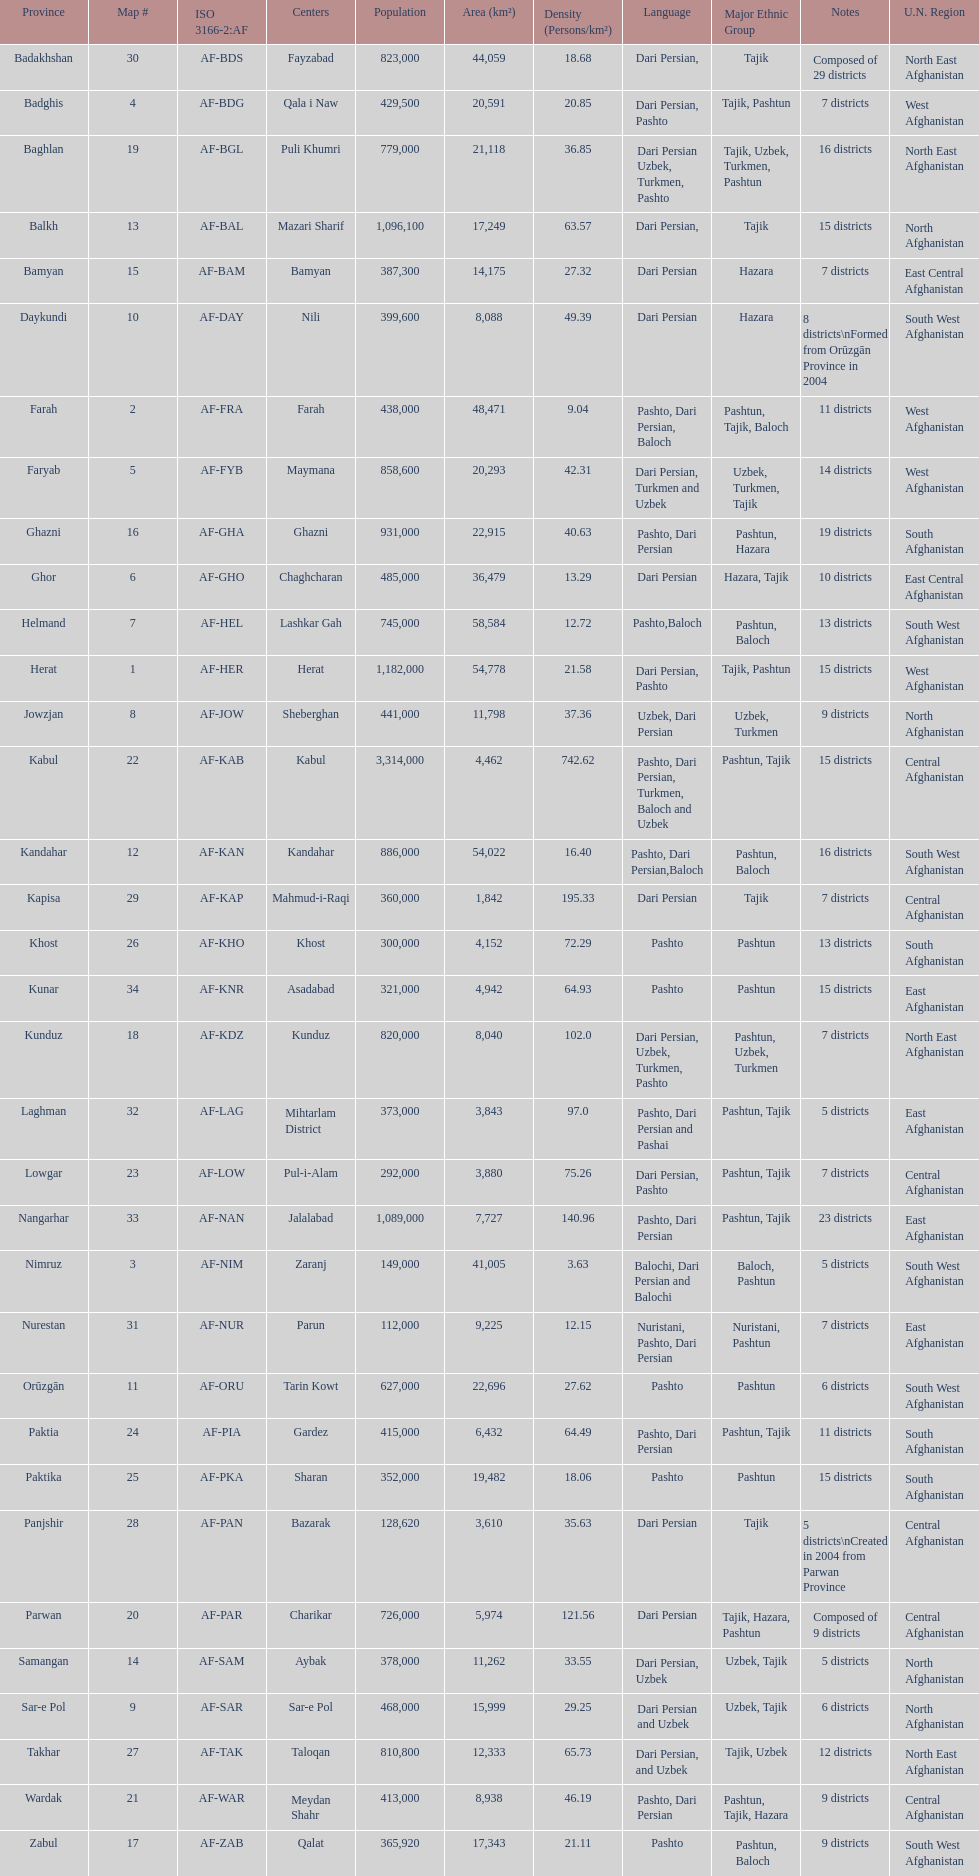How many provinces have pashto as one of their languages 20. Give me the full table as a dictionary. {'header': ['Province', 'Map #', 'ISO 3166-2:AF', 'Centers', 'Population', 'Area (km²)', 'Density (Persons/km²)', 'Language', 'Major Ethnic Group', 'Notes', 'U.N. Region'], 'rows': [['Badakhshan', '30', 'AF-BDS', 'Fayzabad', '823,000', '44,059', '18.68', 'Dari Persian,', 'Tajik', 'Composed of 29 districts', 'North East Afghanistan'], ['Badghis', '4', 'AF-BDG', 'Qala i Naw', '429,500', '20,591', '20.85', 'Dari Persian, Pashto', 'Tajik, Pashtun', '7 districts', 'West Afghanistan'], ['Baghlan', '19', 'AF-BGL', 'Puli Khumri', '779,000', '21,118', '36.85', 'Dari Persian Uzbek, Turkmen, Pashto', 'Tajik, Uzbek, Turkmen, Pashtun', '16 districts', 'North East Afghanistan'], ['Balkh', '13', 'AF-BAL', 'Mazari Sharif', '1,096,100', '17,249', '63.57', 'Dari Persian,', 'Tajik', '15 districts', 'North Afghanistan'], ['Bamyan', '15', 'AF-BAM', 'Bamyan', '387,300', '14,175', '27.32', 'Dari Persian', 'Hazara', '7 districts', 'East Central Afghanistan'], ['Daykundi', '10', 'AF-DAY', 'Nili', '399,600', '8,088', '49.39', 'Dari Persian', 'Hazara', '8 districts\\nFormed from Orūzgān Province in 2004', 'South West Afghanistan'], ['Farah', '2', 'AF-FRA', 'Farah', '438,000', '48,471', '9.04', 'Pashto, Dari Persian, Baloch', 'Pashtun, Tajik, Baloch', '11 districts', 'West Afghanistan'], ['Faryab', '5', 'AF-FYB', 'Maymana', '858,600', '20,293', '42.31', 'Dari Persian, Turkmen and Uzbek', 'Uzbek, Turkmen, Tajik', '14 districts', 'West Afghanistan'], ['Ghazni', '16', 'AF-GHA', 'Ghazni', '931,000', '22,915', '40.63', 'Pashto, Dari Persian', 'Pashtun, Hazara', '19 districts', 'South Afghanistan'], ['Ghor', '6', 'AF-GHO', 'Chaghcharan', '485,000', '36,479', '13.29', 'Dari Persian', 'Hazara, Tajik', '10 districts', 'East Central Afghanistan'], ['Helmand', '7', 'AF-HEL', 'Lashkar Gah', '745,000', '58,584', '12.72', 'Pashto,Baloch', 'Pashtun, Baloch', '13 districts', 'South West Afghanistan'], ['Herat', '1', 'AF-HER', 'Herat', '1,182,000', '54,778', '21.58', 'Dari Persian, Pashto', 'Tajik, Pashtun', '15 districts', 'West Afghanistan'], ['Jowzjan', '8', 'AF-JOW', 'Sheberghan', '441,000', '11,798', '37.36', 'Uzbek, Dari Persian', 'Uzbek, Turkmen', '9 districts', 'North Afghanistan'], ['Kabul', '22', 'AF-KAB', 'Kabul', '3,314,000', '4,462', '742.62', 'Pashto, Dari Persian, Turkmen, Baloch and Uzbek', 'Pashtun, Tajik', '15 districts', 'Central Afghanistan'], ['Kandahar', '12', 'AF-KAN', 'Kandahar', '886,000', '54,022', '16.40', 'Pashto, Dari Persian,Baloch', 'Pashtun, Baloch', '16 districts', 'South West Afghanistan'], ['Kapisa', '29', 'AF-KAP', 'Mahmud-i-Raqi', '360,000', '1,842', '195.33', 'Dari Persian', 'Tajik', '7 districts', 'Central Afghanistan'], ['Khost', '26', 'AF-KHO', 'Khost', '300,000', '4,152', '72.29', 'Pashto', 'Pashtun', '13 districts', 'South Afghanistan'], ['Kunar', '34', 'AF-KNR', 'Asadabad', '321,000', '4,942', '64.93', 'Pashto', 'Pashtun', '15 districts', 'East Afghanistan'], ['Kunduz', '18', 'AF-KDZ', 'Kunduz', '820,000', '8,040', '102.0', 'Dari Persian, Uzbek, Turkmen, Pashto', 'Pashtun, Uzbek, Turkmen', '7 districts', 'North East Afghanistan'], ['Laghman', '32', 'AF-LAG', 'Mihtarlam District', '373,000', '3,843', '97.0', 'Pashto, Dari Persian and Pashai', 'Pashtun, Tajik', '5 districts', 'East Afghanistan'], ['Lowgar', '23', 'AF-LOW', 'Pul-i-Alam', '292,000', '3,880', '75.26', 'Dari Persian, Pashto', 'Pashtun, Tajik', '7 districts', 'Central Afghanistan'], ['Nangarhar', '33', 'AF-NAN', 'Jalalabad', '1,089,000', '7,727', '140.96', 'Pashto, Dari Persian', 'Pashtun, Tajik', '23 districts', 'East Afghanistan'], ['Nimruz', '3', 'AF-NIM', 'Zaranj', '149,000', '41,005', '3.63', 'Balochi, Dari Persian and Balochi', 'Baloch, Pashtun', '5 districts', 'South West Afghanistan'], ['Nurestan', '31', 'AF-NUR', 'Parun', '112,000', '9,225', '12.15', 'Nuristani, Pashto, Dari Persian', 'Nuristani, Pashtun', '7 districts', 'East Afghanistan'], ['Orūzgān', '11', 'AF-ORU', 'Tarin Kowt', '627,000', '22,696', '27.62', 'Pashto', 'Pashtun', '6 districts', 'South West Afghanistan'], ['Paktia', '24', 'AF-PIA', 'Gardez', '415,000', '6,432', '64.49', 'Pashto, Dari Persian', 'Pashtun, Tajik', '11 districts', 'South Afghanistan'], ['Paktika', '25', 'AF-PKA', 'Sharan', '352,000', '19,482', '18.06', 'Pashto', 'Pashtun', '15 districts', 'South Afghanistan'], ['Panjshir', '28', 'AF-PAN', 'Bazarak', '128,620', '3,610', '35.63', 'Dari Persian', 'Tajik', '5 districts\\nCreated in 2004 from Parwan Province', 'Central Afghanistan'], ['Parwan', '20', 'AF-PAR', 'Charikar', '726,000', '5,974', '121.56', 'Dari Persian', 'Tajik, Hazara, Pashtun', 'Composed of 9 districts', 'Central Afghanistan'], ['Samangan', '14', 'AF-SAM', 'Aybak', '378,000', '11,262', '33.55', 'Dari Persian, Uzbek', 'Uzbek, Tajik', '5 districts', 'North Afghanistan'], ['Sar-e Pol', '9', 'AF-SAR', 'Sar-e Pol', '468,000', '15,999', '29.25', 'Dari Persian and Uzbek', 'Uzbek, Tajik', '6 districts', 'North Afghanistan'], ['Takhar', '27', 'AF-TAK', 'Taloqan', '810,800', '12,333', '65.73', 'Dari Persian, and Uzbek', 'Tajik, Uzbek', '12 districts', 'North East Afghanistan'], ['Wardak', '21', 'AF-WAR', 'Meydan Shahr', '413,000', '8,938', '46.19', 'Pashto, Dari Persian', 'Pashtun, Tajik, Hazara', '9 districts', 'Central Afghanistan'], ['Zabul', '17', 'AF-ZAB', 'Qalat', '365,920', '17,343', '21.11', 'Pashto', 'Pashtun, Baloch', '9 districts', 'South West Afghanistan']]} 